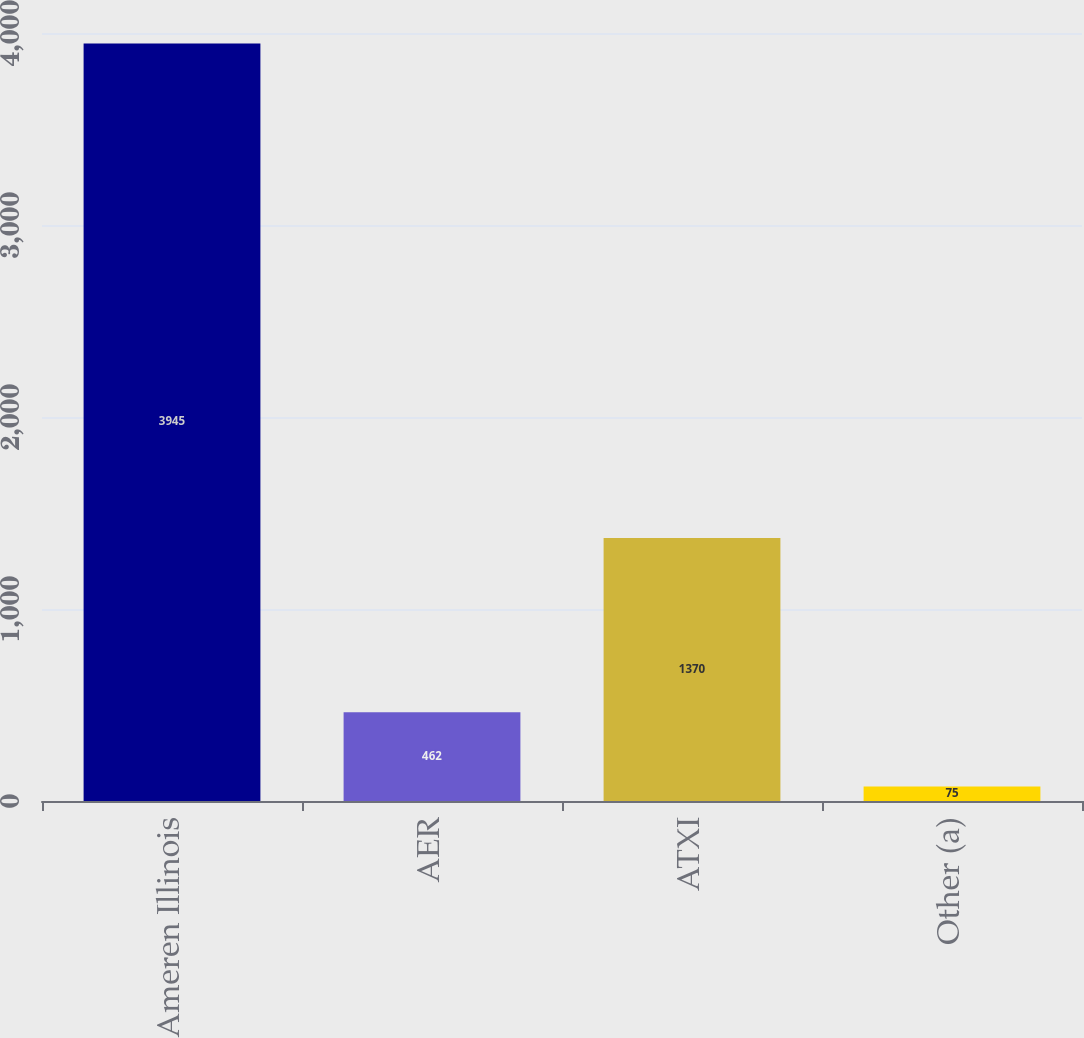Convert chart. <chart><loc_0><loc_0><loc_500><loc_500><bar_chart><fcel>Ameren Illinois<fcel>AER<fcel>ATXI<fcel>Other (a)<nl><fcel>3945<fcel>462<fcel>1370<fcel>75<nl></chart> 